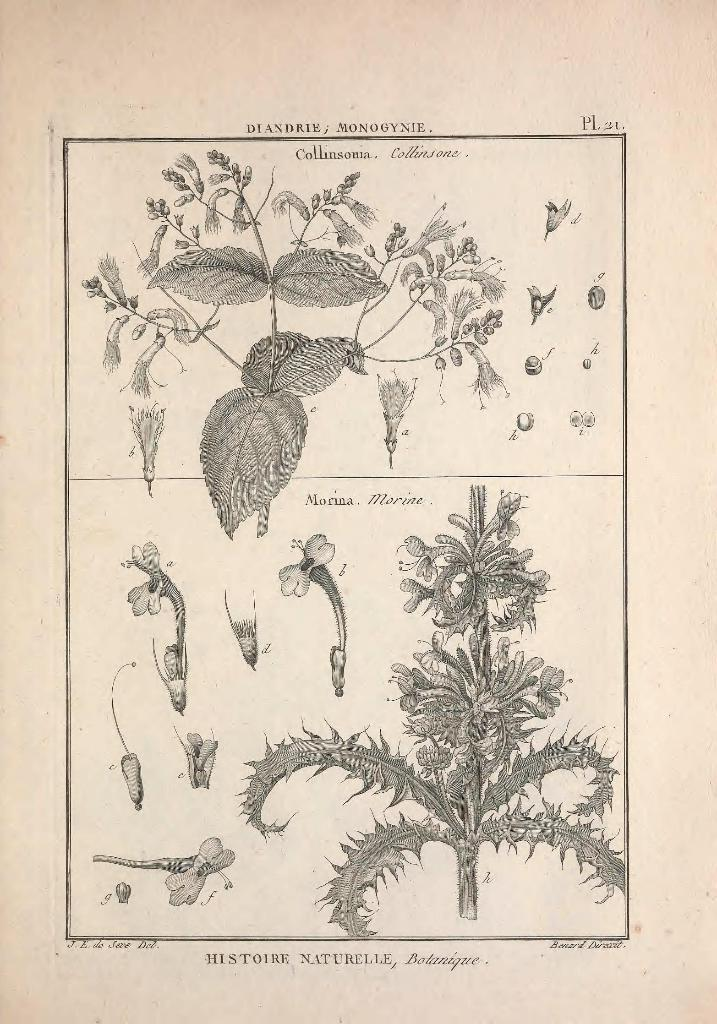What type of images are present in the picture? The image contains pictures of plants and flowers printed on paper. Is there any text in the image? Yes, there is text at the bottom of the image. Where is the girl sitting on the net in the image? There is no girl or net present in the image; it only contains pictures of plants and flowers printed on paper and text at the bottom. 